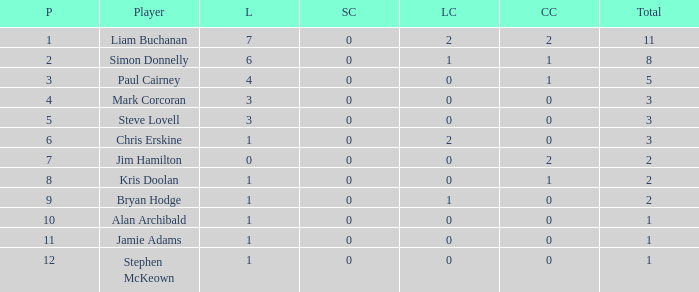What is bryan hodge's player number 1.0. 